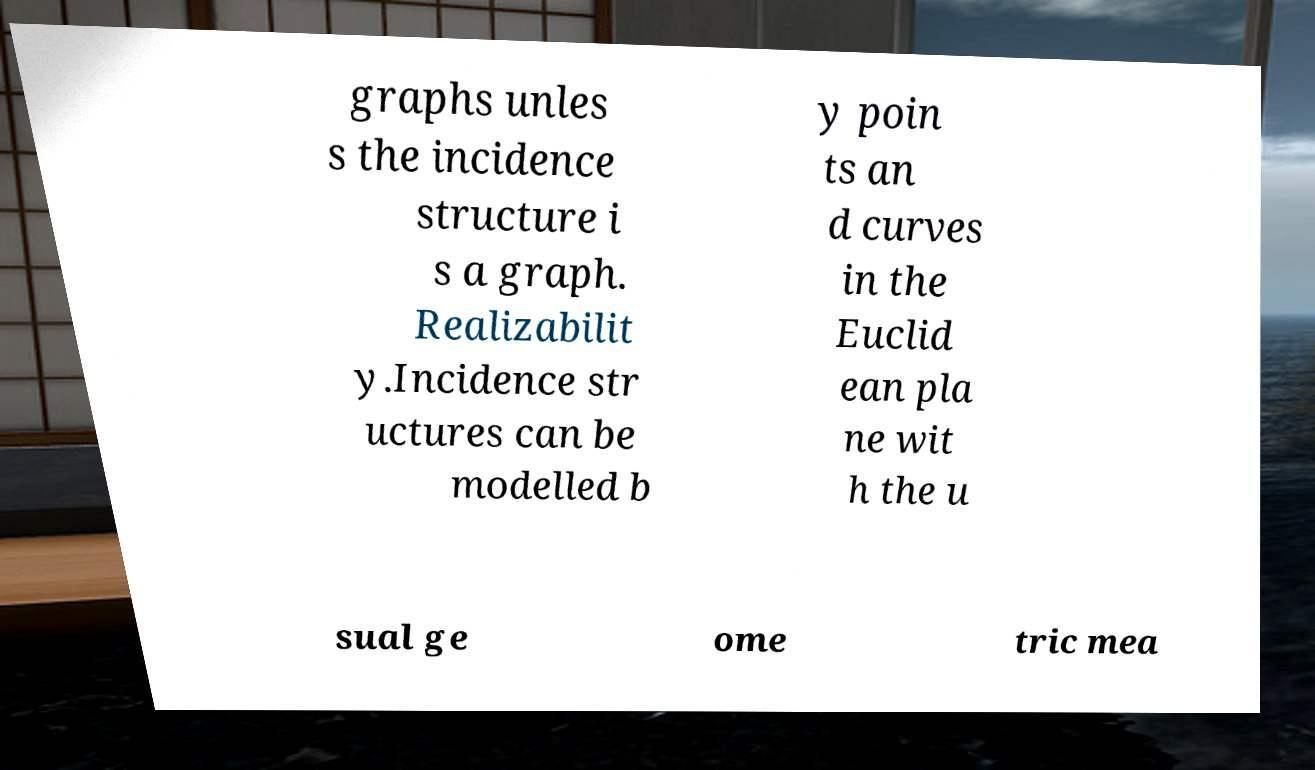I need the written content from this picture converted into text. Can you do that? graphs unles s the incidence structure i s a graph. Realizabilit y.Incidence str uctures can be modelled b y poin ts an d curves in the Euclid ean pla ne wit h the u sual ge ome tric mea 